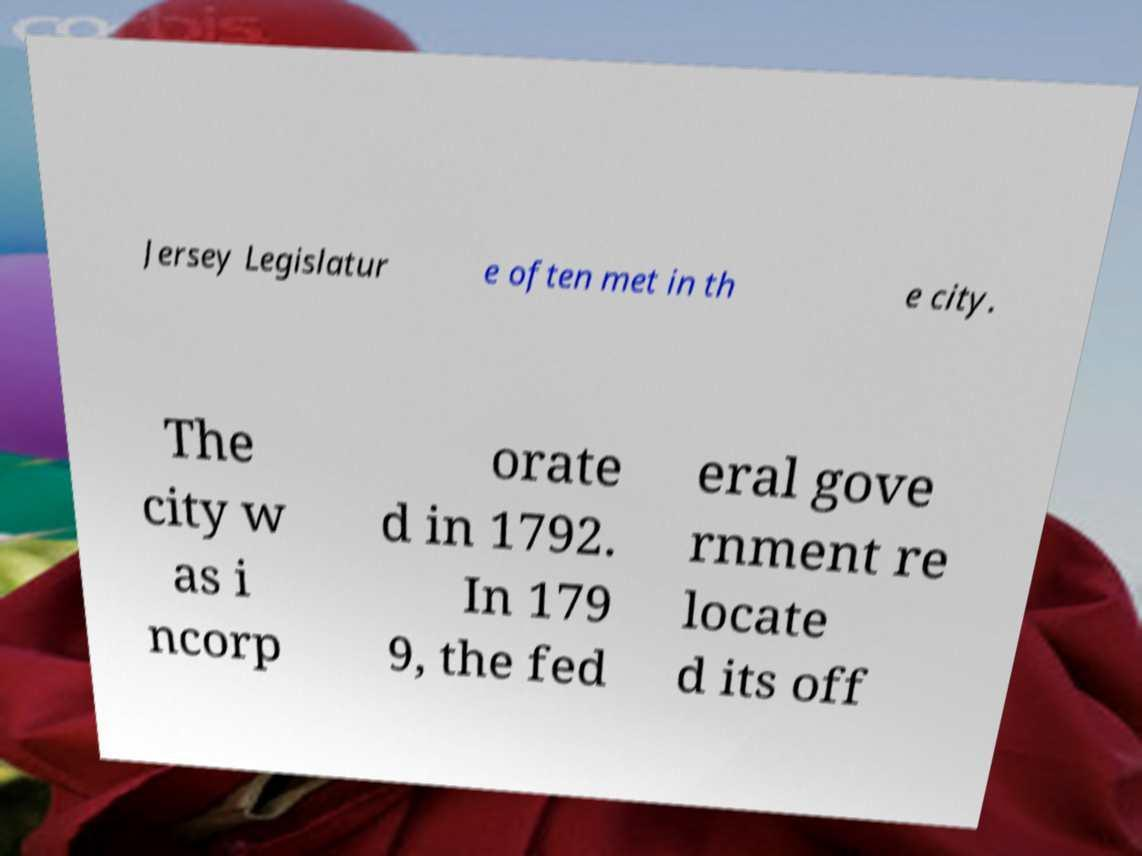Please read and relay the text visible in this image. What does it say? Jersey Legislatur e often met in th e city. The city w as i ncorp orate d in 1792. In 179 9, the fed eral gove rnment re locate d its off 